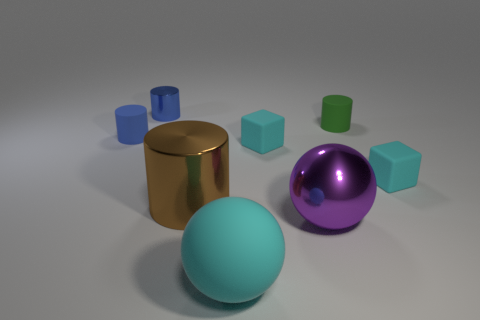Subtract all blue matte cylinders. How many cylinders are left? 3 Subtract all brown cylinders. How many cylinders are left? 3 Add 1 small brown matte cubes. How many objects exist? 9 Subtract all spheres. How many objects are left? 6 Subtract 2 spheres. How many spheres are left? 0 Subtract all purple cylinders. Subtract all yellow cubes. How many cylinders are left? 4 Subtract all yellow blocks. How many blue cylinders are left? 2 Subtract all tiny blocks. Subtract all small blue matte objects. How many objects are left? 5 Add 5 large cylinders. How many large cylinders are left? 6 Add 6 large red things. How many large red things exist? 6 